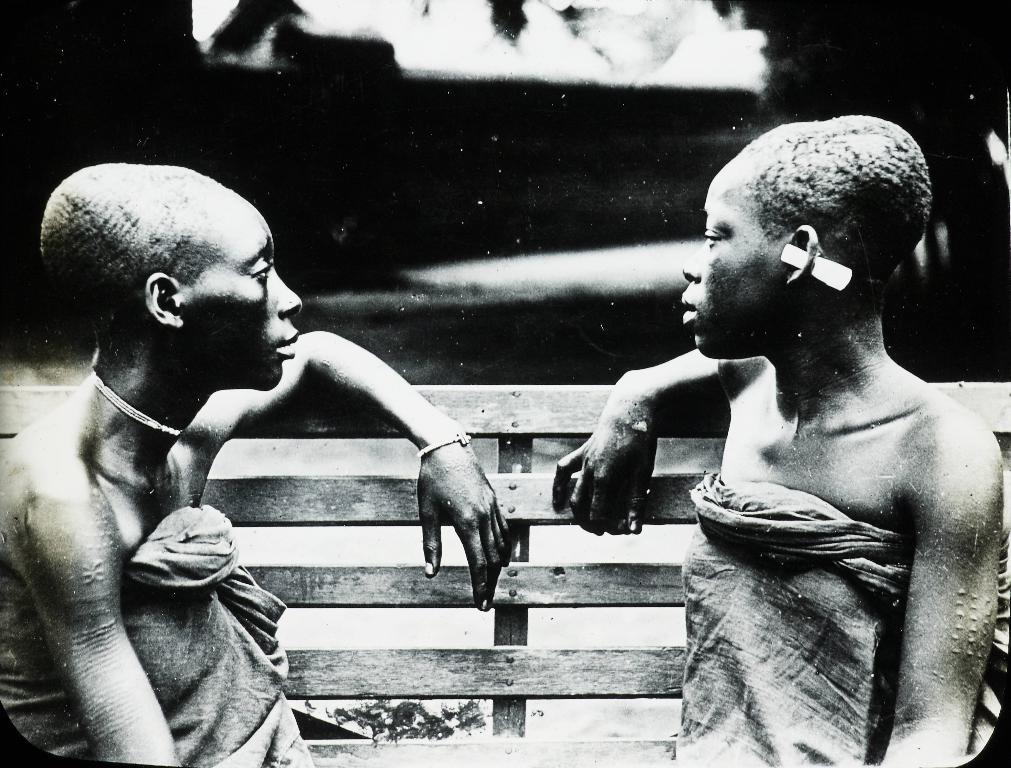What is the color scheme of the image? The image is in black and white. How many people are in the image? There are two people in the image. What are the two people doing in the image? The two people are sitting on a bench. What type of wine is being served to the people on the bench in the image? There is no wine present in the image, as it is in black and white and does not depict any food or drink. 